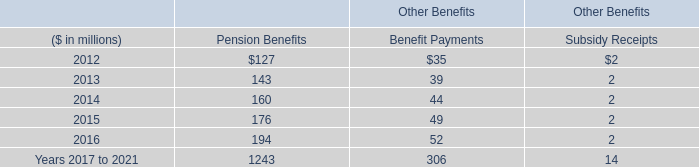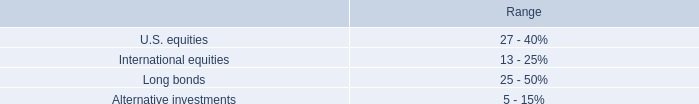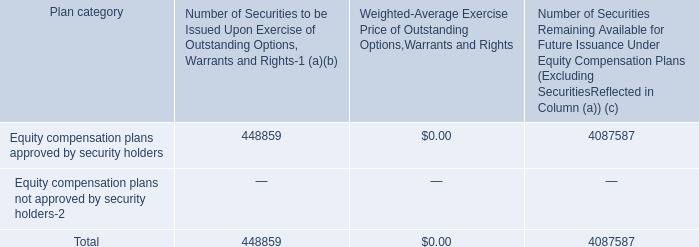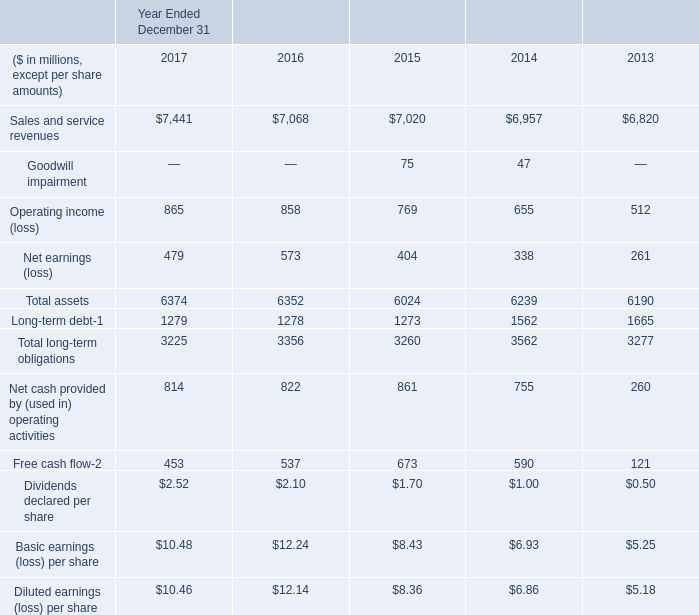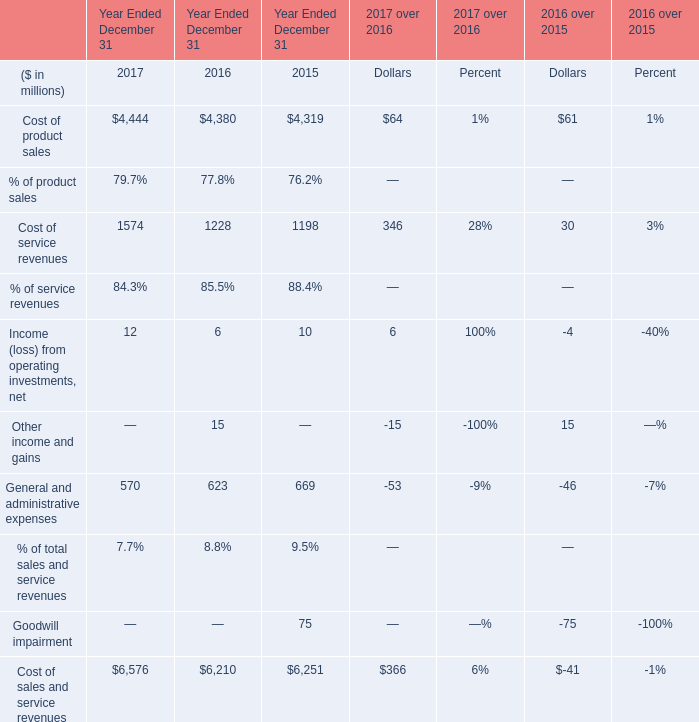Which element has the second largest number in 2017? 
Answer: Cost of service revenues. 